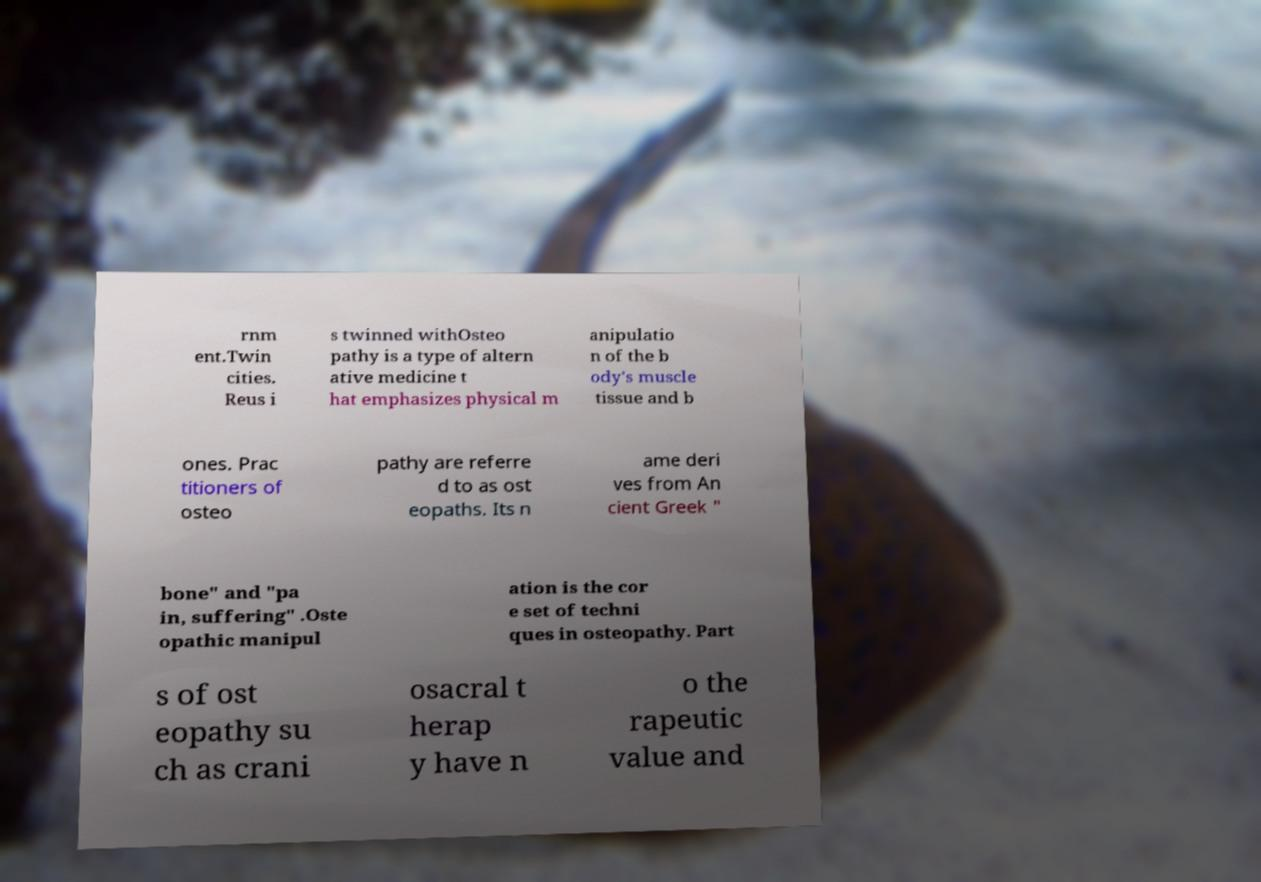Could you assist in decoding the text presented in this image and type it out clearly? rnm ent.Twin cities. Reus i s twinned withOsteo pathy is a type of altern ative medicine t hat emphasizes physical m anipulatio n of the b ody's muscle tissue and b ones. Prac titioners of osteo pathy are referre d to as ost eopaths. Its n ame deri ves from An cient Greek " bone" and "pa in, suffering" .Oste opathic manipul ation is the cor e set of techni ques in osteopathy. Part s of ost eopathy su ch as crani osacral t herap y have n o the rapeutic value and 